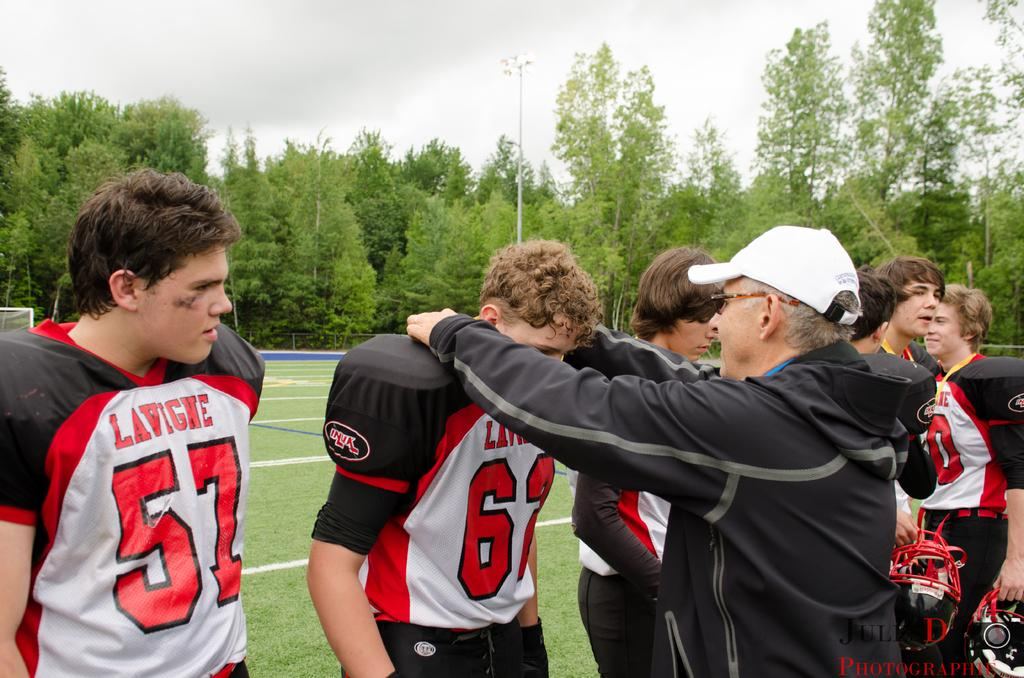<image>
Relay a brief, clear account of the picture shown. A young man wearing a white and black jersey that says "Lavigne" stands next to others and an older man in a white hat. 